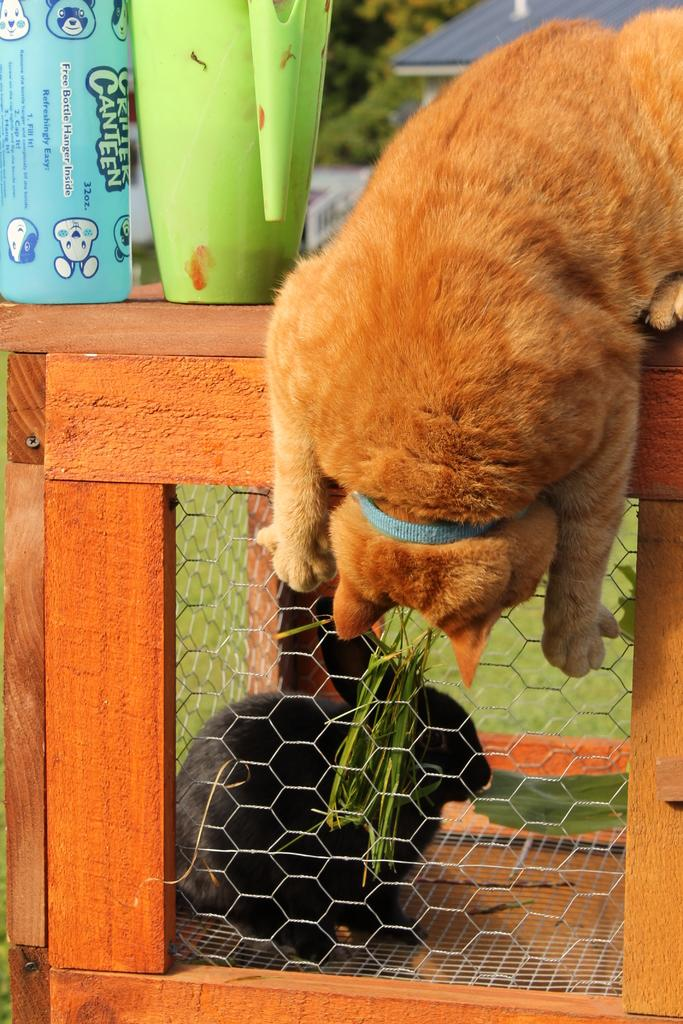What animal is sitting on the wooden surface in the image? There is a cat on the wooden surface in the image. What else can be seen on the wooden surface besides the cat? There are glasses on the wooden surface. What is the rabbit's location and condition in the image? The rabbit is inside a mesh box, and grass is visible through the mesh box. What can be seen in the background of the image? The background of the image includes a roof top. Where is the oven located in the image? There is no oven present in the image. Can you see an uncle in the image? There is no uncle present in the image. 